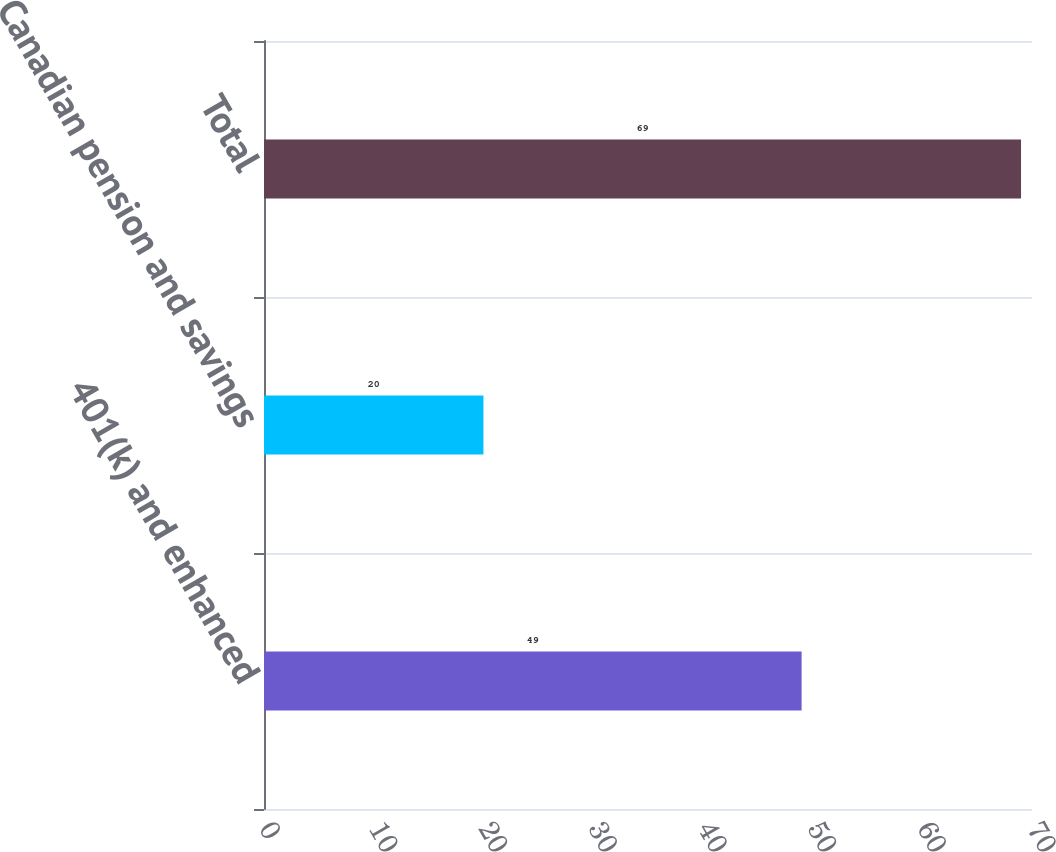Convert chart to OTSL. <chart><loc_0><loc_0><loc_500><loc_500><bar_chart><fcel>401(k) and enhanced<fcel>Canadian pension and savings<fcel>Total<nl><fcel>49<fcel>20<fcel>69<nl></chart> 